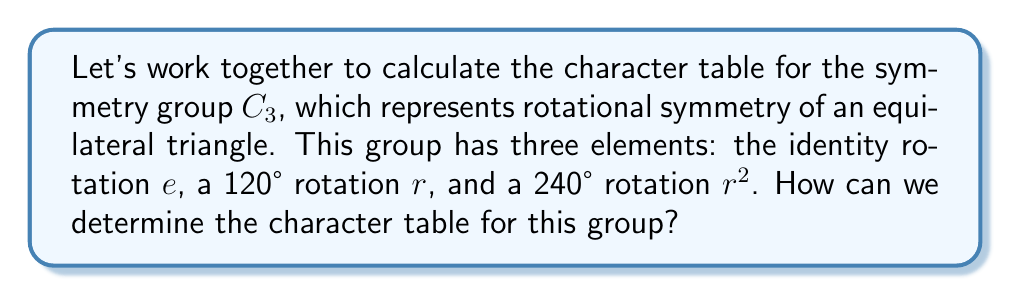Provide a solution to this math problem. Let's approach this step-by-step:

1) First, we need to identify the conjugacy classes of $C_3$:
   - Each element is in its own conjugacy class: $\{e\}$, $\{r\}$, $\{r^2\}$

2) The number of irreducible representations equals the number of conjugacy classes, so we have 3 irreducible representations.

3) Let's call these representations $\chi_1$, $\chi_2$, and $\chi_3$.

4) $\chi_1$ is always the trivial representation, where every element maps to 1.

5) For the other representations, we can use the fact that $C_3$ is abelian, so each irreducible representation is one-dimensional.

6) Let $\omega = e^{2\pi i/3} = -\frac{1}{2} + i\frac{\sqrt{3}}{2}$ be the complex cube root of unity.

7) The character values for $r$ in $\chi_2$ and $\chi_3$ must be powers of $\omega$:
   $\chi_2(r) = \omega$ and $\chi_3(r) = \omega^2$

8) For $r^2$, we have:
   $\chi_2(r^2) = (\chi_2(r))^2 = \omega^2$
   $\chi_3(r^2) = (\chi_3(r))^2 = (\omega^2)^2 = \omega$

9) Now we can construct the character table:

   $$
   \begin{array}{c|ccc}
    C_3 & e & r & r^2 \\
    \hline
    \chi_1 & 1 & 1 & 1 \\
    \chi_2 & 1 & \omega & \omega^2 \\
    \chi_3 & 1 & \omega^2 & \omega
   \end{array}
   $$

10) We can verify this table using the orthogonality relations and the fact that $\sum_i |\chi_i(g)|^2 = |G| = 3$ for each column.
Answer: $$
\begin{array}{c|ccc}
C_3 & e & r & r^2 \\
\hline
\chi_1 & 1 & 1 & 1 \\
\chi_2 & 1 & \omega & \omega^2 \\
\chi_3 & 1 & \omega^2 & \omega
\end{array}
$$
where $\omega = e^{2\pi i/3}$ 